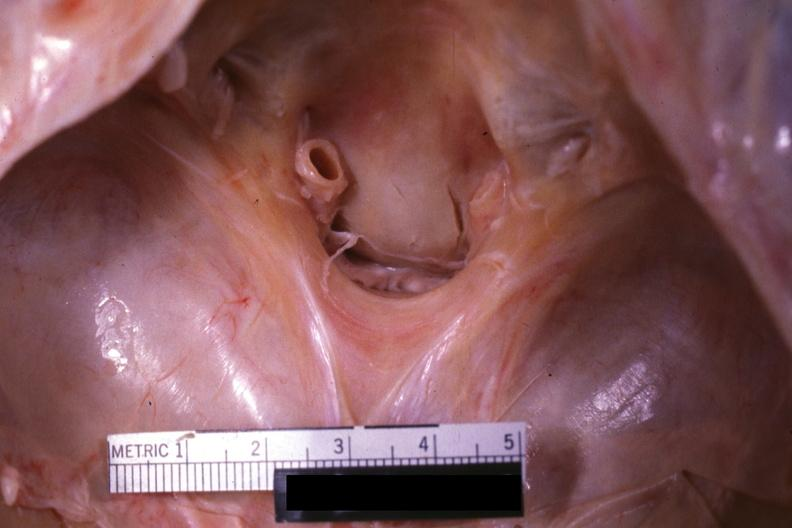does this image show close-up view of foramen magnum?
Answer the question using a single word or phrase. Yes 